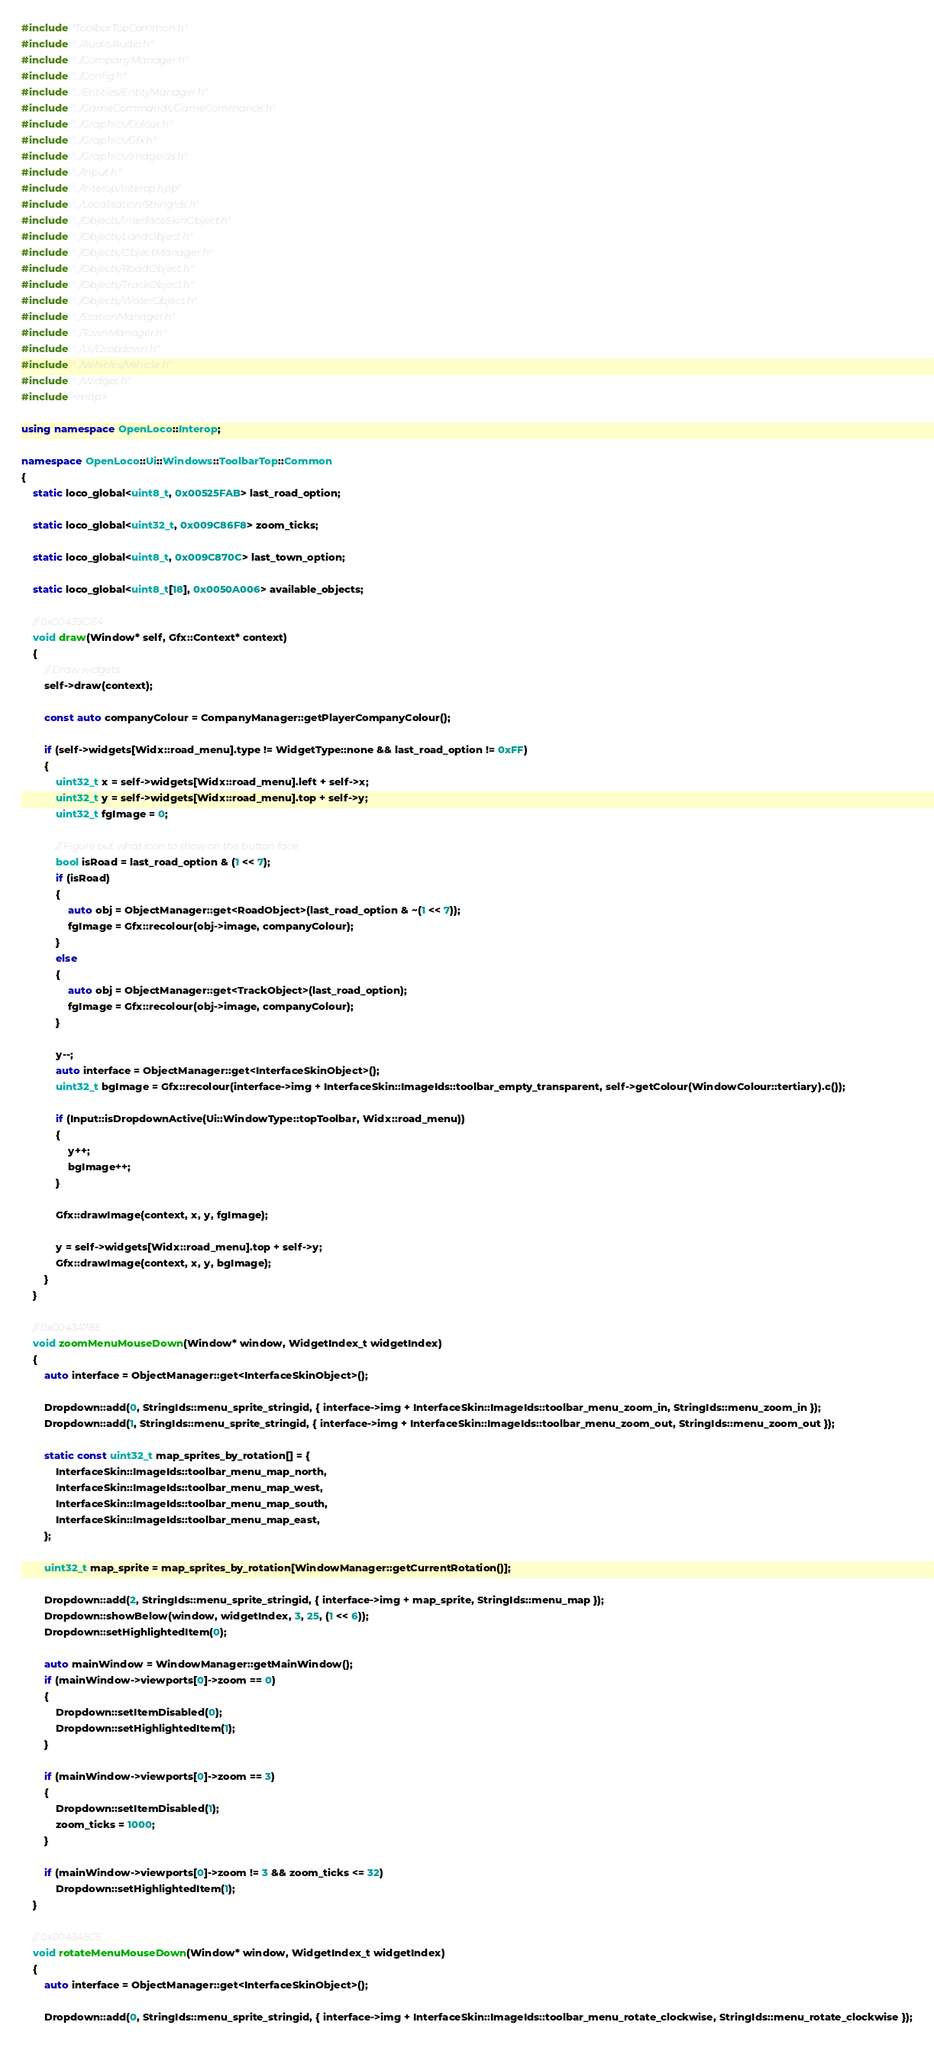<code> <loc_0><loc_0><loc_500><loc_500><_C++_>#include "ToolbarTopCommon.h"
#include "../Audio/Audio.h"
#include "../CompanyManager.h"
#include "../Config.h"
#include "../Entities/EntityManager.h"
#include "../GameCommands/GameCommands.h"
#include "../Graphics/Colour.h"
#include "../Graphics/Gfx.h"
#include "../Graphics/ImageIds.h"
#include "../Input.h"
#include "../Interop/Interop.hpp"
#include "../Localisation/StringIds.h"
#include "../Objects/InterfaceSkinObject.h"
#include "../Objects/LandObject.h"
#include "../Objects/ObjectManager.h"
#include "../Objects/RoadObject.h"
#include "../Objects/TrackObject.h"
#include "../Objects/WaterObject.h"
#include "../StationManager.h"
#include "../TownManager.h"
#include "../Ui/Dropdown.h"
#include "../Vehicles/Vehicle.h"
#include "../Widget.h"
#include <map>

using namespace OpenLoco::Interop;

namespace OpenLoco::Ui::Windows::ToolbarTop::Common
{
    static loco_global<uint8_t, 0x00525FAB> last_road_option;

    static loco_global<uint32_t, 0x009C86F8> zoom_ticks;

    static loco_global<uint8_t, 0x009C870C> last_town_option;

    static loco_global<uint8_t[18], 0x0050A006> available_objects;

    // 0x00439DE4
    void draw(Window* self, Gfx::Context* context)
    {
        // Draw widgets.
        self->draw(context);

        const auto companyColour = CompanyManager::getPlayerCompanyColour();

        if (self->widgets[Widx::road_menu].type != WidgetType::none && last_road_option != 0xFF)
        {
            uint32_t x = self->widgets[Widx::road_menu].left + self->x;
            uint32_t y = self->widgets[Widx::road_menu].top + self->y;
            uint32_t fgImage = 0;

            // Figure out what icon to show on the button face.
            bool isRoad = last_road_option & (1 << 7);
            if (isRoad)
            {
                auto obj = ObjectManager::get<RoadObject>(last_road_option & ~(1 << 7));
                fgImage = Gfx::recolour(obj->image, companyColour);
            }
            else
            {
                auto obj = ObjectManager::get<TrackObject>(last_road_option);
                fgImage = Gfx::recolour(obj->image, companyColour);
            }

            y--;
            auto interface = ObjectManager::get<InterfaceSkinObject>();
            uint32_t bgImage = Gfx::recolour(interface->img + InterfaceSkin::ImageIds::toolbar_empty_transparent, self->getColour(WindowColour::tertiary).c());

            if (Input::isDropdownActive(Ui::WindowType::topToolbar, Widx::road_menu))
            {
                y++;
                bgImage++;
            }

            Gfx::drawImage(context, x, y, fgImage);

            y = self->widgets[Widx::road_menu].top + self->y;
            Gfx::drawImage(context, x, y, bgImage);
        }
    }

    // 0x0043A78E
    void zoomMenuMouseDown(Window* window, WidgetIndex_t widgetIndex)
    {
        auto interface = ObjectManager::get<InterfaceSkinObject>();

        Dropdown::add(0, StringIds::menu_sprite_stringid, { interface->img + InterfaceSkin::ImageIds::toolbar_menu_zoom_in, StringIds::menu_zoom_in });
        Dropdown::add(1, StringIds::menu_sprite_stringid, { interface->img + InterfaceSkin::ImageIds::toolbar_menu_zoom_out, StringIds::menu_zoom_out });

        static const uint32_t map_sprites_by_rotation[] = {
            InterfaceSkin::ImageIds::toolbar_menu_map_north,
            InterfaceSkin::ImageIds::toolbar_menu_map_west,
            InterfaceSkin::ImageIds::toolbar_menu_map_south,
            InterfaceSkin::ImageIds::toolbar_menu_map_east,
        };

        uint32_t map_sprite = map_sprites_by_rotation[WindowManager::getCurrentRotation()];

        Dropdown::add(2, StringIds::menu_sprite_stringid, { interface->img + map_sprite, StringIds::menu_map });
        Dropdown::showBelow(window, widgetIndex, 3, 25, (1 << 6));
        Dropdown::setHighlightedItem(0);

        auto mainWindow = WindowManager::getMainWindow();
        if (mainWindow->viewports[0]->zoom == 0)
        {
            Dropdown::setItemDisabled(0);
            Dropdown::setHighlightedItem(1);
        }

        if (mainWindow->viewports[0]->zoom == 3)
        {
            Dropdown::setItemDisabled(1);
            zoom_ticks = 1000;
        }

        if (mainWindow->viewports[0]->zoom != 3 && zoom_ticks <= 32)
            Dropdown::setHighlightedItem(1);
    }

    // 0x0043A5C5
    void rotateMenuMouseDown(Window* window, WidgetIndex_t widgetIndex)
    {
        auto interface = ObjectManager::get<InterfaceSkinObject>();

        Dropdown::add(0, StringIds::menu_sprite_stringid, { interface->img + InterfaceSkin::ImageIds::toolbar_menu_rotate_clockwise, StringIds::menu_rotate_clockwise });</code> 